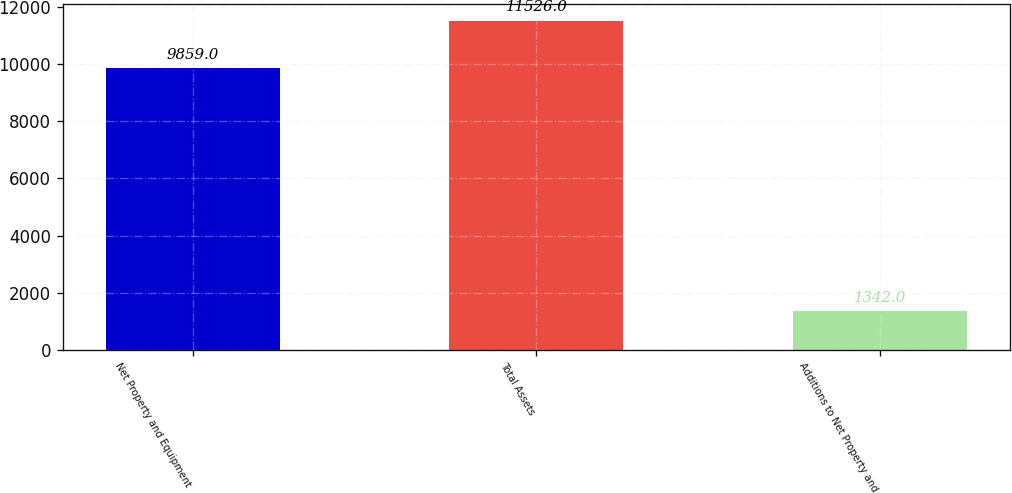<chart> <loc_0><loc_0><loc_500><loc_500><bar_chart><fcel>Net Property and Equipment<fcel>Total Assets<fcel>Additions to Net Property and<nl><fcel>9859<fcel>11526<fcel>1342<nl></chart> 